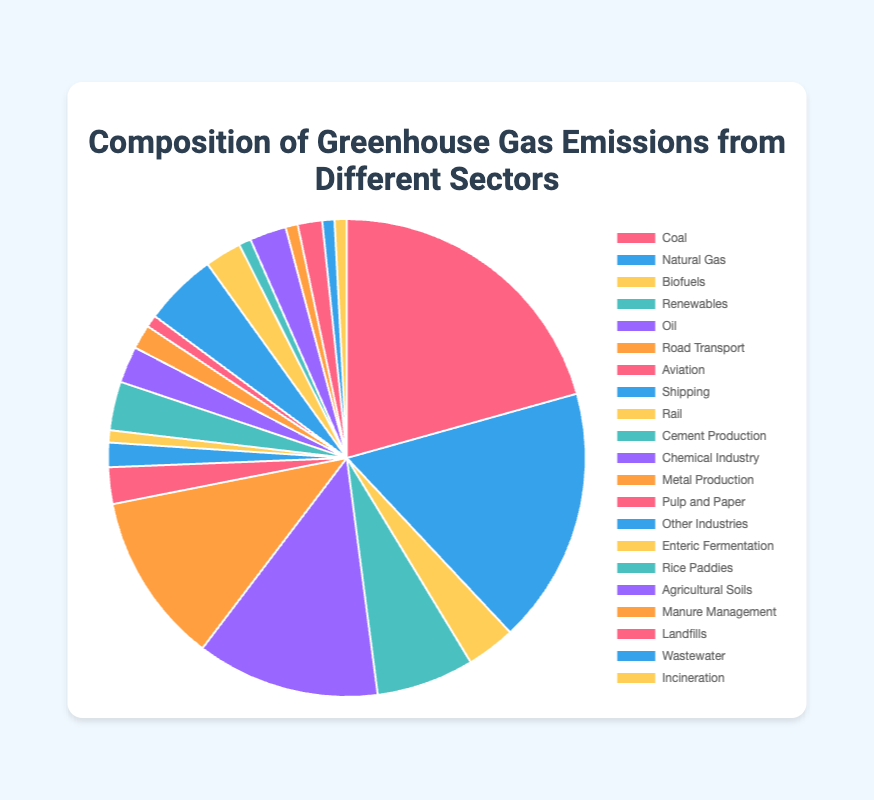What percentage of the greenhouse gas emissions come from Oil within the Energy Production sector? The Energy Production sector has several categories including Coal (25%), Natural Gas (21%), Biofuels (4%), Renewables (8%), and Oil (15%). The percentage contribution of Oil can be directly read from the pie chart segment labeled "Oil."
Answer: 15% Which sector contributes the most to greenhouse gas emissions? By visually comparing the sizes of each colored segment associated with different sectors, it is apparent that the largest segment belongs to the Energy Production sector, specifically Coal with 25%. The overall largest sector, by visual inspection, is the Energy Production in general.
Answer: Energy Production (Coal) What is the combined percentage of emissions from Road Transport and Aviation? From the pie chart, Road Transport contributes 14% and Aviation contributes 3% to greenhouse gas emissions. Summing these values gives 14% + 3% = 17%.
Answer: 17% How do emissions from Biofuels compare to emissions from Landfills? The chart indicates that Biofuels have a contribution of 4%, while Landfills contribute 2%. Comparing these values directly, Biofuels' emissions are twice as large as those from Landfills (4% > 2%).
Answer: Biofuels (4%) > Landfills (2%) What are the emissions from Cement Production and Chemical Industry combined? Referencing the pie chart, Cement Production accounts for 4% and Chemical Industry accounts for 3%. Adding these percentages together results in 4% + 3% = 7%.
Answer: 7% Which sector shows the least contribution to greenhouse gas emissions and what is its percentage? The smallest segments in the pie chart are associated with Rail, Manure Management, Wastewater, and Incineration, each contributing 1%.
Answer: Rail, Manure Management, Wastewater, Incineration (1%) What is the total percentage of emissions coming from Agriculture? The Agriculture sector comprises Enteric Fermentation (3%), Rice Paddies (1%), Agricultural Soils (3%), and Manure Management (1%). Summing these values gives 3% + 1% + 3% + 1% = 8%.
Answer: 8% Compare the emissions percentages between Renewables within Energy Production and Other Industries within the Industry sector. The pie chart shows Renewables contributing 8% and Other Industries contributing 6% to greenhouse gas emissions. Comparing these visually, Renewables have a higher percentage than Other Industries (8% > 6%).
Answer: Renewables (8%) > Other Industries (6%) What is the sum of emissions from all the categories under the Waste sector? Under the Waste sector, Landfills (2%), Wastewater (1%), and Incineration (1%) are listed. The total emissions from this sector are obtained by adding these percentages: 2% + 1% + 1% = 4%.
Answer: 4% What is the difference between the emissions from Metal Production and Pulp and Paper within the Industry sector? From the pie chart, Metal Production contributes 2% to greenhouse gas emissions, while Pulp and Paper contribute 1%. The difference between these two values is 2% - 1% = 1%.
Answer: 1% 